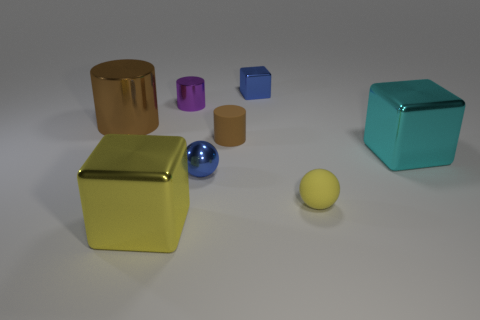How many blue blocks are to the left of the blue object that is behind the tiny purple cylinder?
Ensure brevity in your answer.  0. Are there any other tiny things that have the same shape as the cyan metal object?
Offer a terse response. Yes. What is the color of the sphere that is on the right side of the matte thing behind the cyan metal block?
Your response must be concise. Yellow. Are there more big green rubber cubes than large cubes?
Keep it short and to the point. No. What number of other shiny cylinders are the same size as the purple cylinder?
Ensure brevity in your answer.  0. Is the purple cylinder made of the same material as the small ball on the left side of the small brown thing?
Your answer should be compact. Yes. Is the number of small purple cylinders less than the number of green matte balls?
Offer a very short reply. No. Is there anything else that has the same color as the big metallic cylinder?
Make the answer very short. Yes. What shape is the cyan thing that is made of the same material as the tiny purple object?
Your response must be concise. Cube. There is a blue object left of the metallic block that is behind the tiny metal cylinder; how many big shiny things are in front of it?
Make the answer very short. 1. 